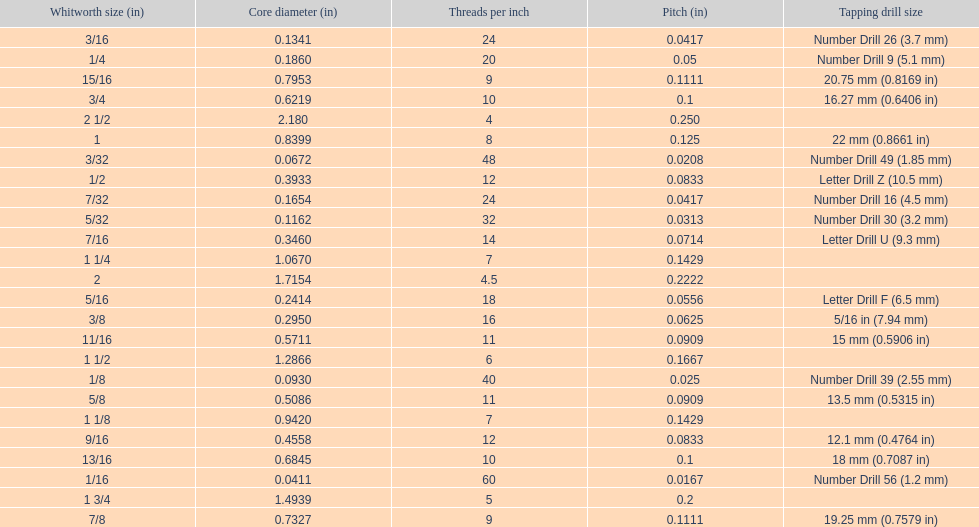What is the core diameter of the last whitworth thread size? 2.180. 